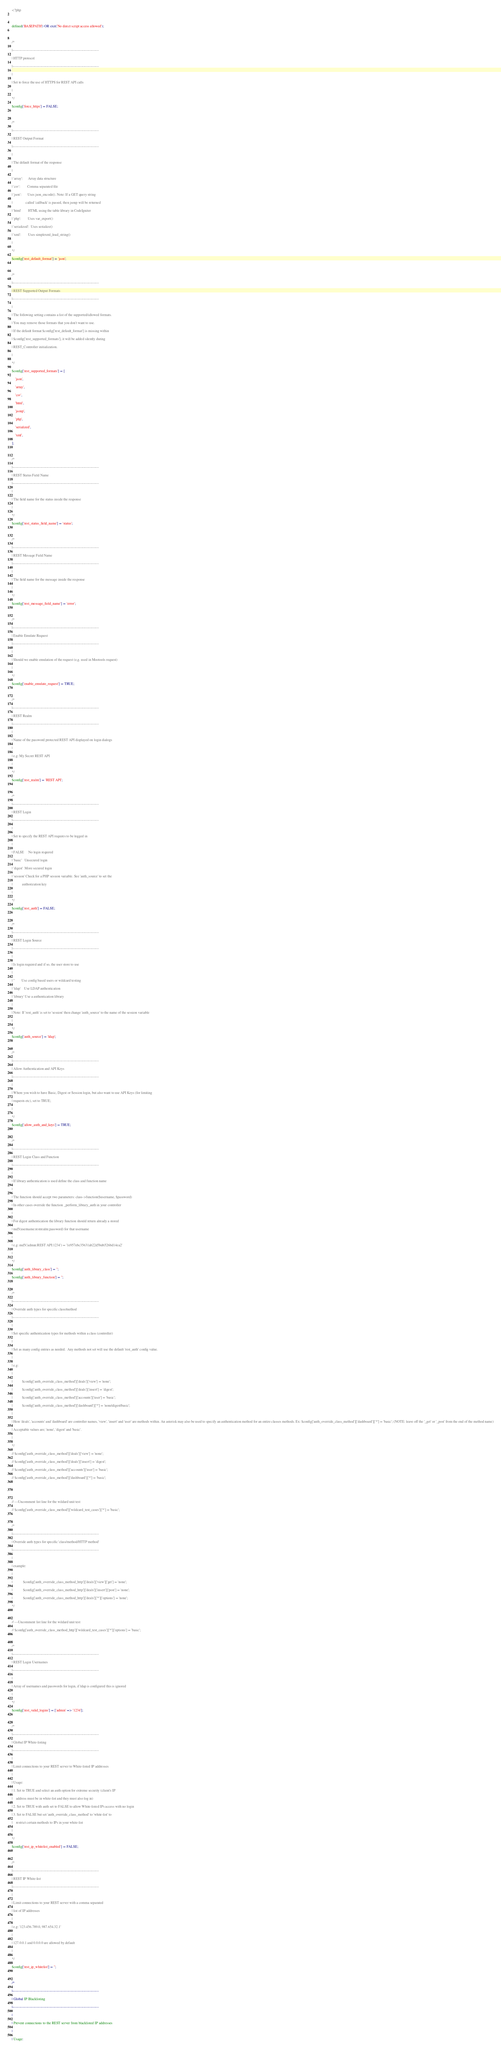Convert code to text. <code><loc_0><loc_0><loc_500><loc_500><_PHP_><?php

defined('BASEPATH') OR exit('No direct script access allowed');

/*
|--------------------------------------------------------------------------
| HTTP protocol
|--------------------------------------------------------------------------
|
| Set to force the use of HTTPS for REST API calls
|
*/
$config['force_https'] = FALSE;

/*
|--------------------------------------------------------------------------
| REST Output Format
|--------------------------------------------------------------------------
|
| The default format of the response
|
| 'array':      Array data structure
| 'csv':        Comma separated file
| 'json':       Uses json_encode(). Note: If a GET query string
|               called 'callback' is passed, then jsonp will be returned
| 'html'        HTML using the table library in CodeIgniter
| 'php':        Uses var_export()
| 'serialized':  Uses serialize()
| 'xml':        Uses simplexml_load_string()
|
*/
$config['rest_default_format'] = 'json';

/*
|--------------------------------------------------------------------------
| REST Supported Output Formats
|--------------------------------------------------------------------------
|
| The following setting contains a list of the supported/allowed formats.
| You may remove those formats that you don't want to use.
| If the default format $config['rest_default_format'] is missing within
| $config['rest_supported_formats'], it will be added silently during
| REST_Controller initialization.
|
*/
$config['rest_supported_formats'] = [
    'json',
    'array',
    'csv',
    'html',
    'jsonp',
    'php',
    'serialized',
    'xml',
];

/*
|--------------------------------------------------------------------------
| REST Status Field Name
|--------------------------------------------------------------------------
|
| The field name for the status inside the response
|
*/
$config['rest_status_field_name'] = 'status';

/*
|--------------------------------------------------------------------------
| REST Message Field Name
|--------------------------------------------------------------------------
|
| The field name for the message inside the response
|
*/
$config['rest_message_field_name'] = 'error';

/*
|--------------------------------------------------------------------------
| Enable Emulate Request
|--------------------------------------------------------------------------
|
| Should we enable emulation of the request (e.g. used in Mootools request)
|
*/
$config['enable_emulate_request'] = TRUE;

/*
|--------------------------------------------------------------------------
| REST Realm
|--------------------------------------------------------------------------
|
| Name of the password protected REST API displayed on login dialogs
|
| e.g: My Secret REST API
|
*/
$config['rest_realm'] = 'REST API';

/*
|--------------------------------------------------------------------------
| REST Login
|--------------------------------------------------------------------------
|
| Set to specify the REST API requires to be logged in
|
| FALSE     No login required
| 'basic'   Unsecured login
| 'digest'  More secured login
| 'session' Check for a PHP session variable. See 'auth_source' to set the
|           authorization key
|
*/
$config['rest_auth'] = FALSE;

/*
|--------------------------------------------------------------------------
| REST Login Source
|--------------------------------------------------------------------------
|
| Is login required and if so, the user store to use
|
| ''        Use config based users or wildcard testing
| 'ldap'    Use LDAP authentication
| 'library' Use a authentication library
|
| Note: If 'rest_auth' is set to 'session' then change 'auth_source' to the name of the session variable
|
*/
$config['auth_source'] = 'ldap';

/*
|--------------------------------------------------------------------------
| Allow Authentication and API Keys
|--------------------------------------------------------------------------
|
| Where you wish to have Basic, Digest or Session login, but also want to use API Keys (for limiting
| requests etc), set to TRUE;
|
*/
$config['allow_auth_and_keys'] = TRUE;

/*
|--------------------------------------------------------------------------
| REST Login Class and Function
|--------------------------------------------------------------------------
|
| If library authentication is used define the class and function name
|
| The function should accept two parameters: class->function($username, $password)
| In other cases override the function _perform_library_auth in your controller
|
| For digest authentication the library function should return already a stored
| md5(username:restrealm:password) for that username
|
| e.g: md5('admin:REST API:1234') = '1e957ebc35631ab22d5bd6526bd14ea2'
|
*/
$config['auth_library_class'] = '';
$config['auth_library_function'] = '';

/*
|--------------------------------------------------------------------------
| Override auth types for specific class/method
|--------------------------------------------------------------------------
|
| Set specific authentication types for methods within a class (controller)
|
| Set as many config entries as needed.  Any methods not set will use the default 'rest_auth' config value.
|
| e.g:
|
|           $config['auth_override_class_method']['deals']['view'] = 'none';
|           $config['auth_override_class_method']['deals']['insert'] = 'digest';
|           $config['auth_override_class_method']['accounts']['user'] = 'basic';
|           $config['auth_override_class_method']['dashboard']['*'] = 'none|digest|basic';
|
| Here 'deals', 'accounts' and 'dashboard' are controller names, 'view', 'insert' and 'user' are methods within. An asterisk may also be used to specify an authentication method for an entire classes methods. Ex: $config['auth_override_class_method']['dashboard']['*'] = 'basic'; (NOTE: leave off the '_get' or '_post' from the end of the method name)
| Acceptable values are; 'none', 'digest' and 'basic'.
|
*/
// $config['auth_override_class_method']['deals']['view'] = 'none';
// $config['auth_override_class_method']['deals']['insert'] = 'digest';
// $config['auth_override_class_method']['accounts']['user'] = 'basic';
// $config['auth_override_class_method']['dashboard']['*'] = 'basic';


// ---Uncomment list line for the wildard unit test
// $config['auth_override_class_method']['wildcard_test_cases']['*'] = 'basic';

/*
|--------------------------------------------------------------------------
| Override auth types for specific 'class/method/HTTP method'
|--------------------------------------------------------------------------
|
| example:
|
|            $config['auth_override_class_method_http']['deals']['view']['get'] = 'none';
|            $config['auth_override_class_method_http']['deals']['insert']['post'] = 'none';
|            $config['auth_override_class_method_http']['deals']['*']['options'] = 'none';
*/

// ---Uncomment list line for the wildard unit test
// $config['auth_override_class_method_http']['wildcard_test_cases']['*']['options'] = 'basic';

/*
|--------------------------------------------------------------------------
| REST Login Usernames
|--------------------------------------------------------------------------
|
| Array of usernames and passwords for login, if ldap is configured this is ignored
|
*/
$config['rest_valid_logins'] = ['admin' => '1234'];

/*
|--------------------------------------------------------------------------
| Global IP White-listing
|--------------------------------------------------------------------------
|
| Limit connections to your REST server to White-listed IP addresses
|
| Usage:
| 1. Set to TRUE and select an auth option for extreme security (client's IP
|    address must be in white-list and they must also log in)
| 2. Set to TRUE with auth set to FALSE to allow White-listed IPs access with no login
| 3. Set to FALSE but set 'auth_override_class_method' to 'white-list' to
|    restrict certain methods to IPs in your white-list
|
*/
$config['rest_ip_whitelist_enabled'] = FALSE;

/*
|--------------------------------------------------------------------------
| REST IP White-list
|--------------------------------------------------------------------------
|
| Limit connections to your REST server with a comma separated
| list of IP addresses
|
| e.g: '123.456.789.0, 987.654.32.1'
|
| 127.0.0.1 and 0.0.0.0 are allowed by default
|
*/
$config['rest_ip_whitelist'] = '';

/*
|--------------------------------------------------------------------------
| Global IP Blacklisting
|--------------------------------------------------------------------------
|
| Prevent connections to the REST server from blacklisted IP addresses
|
| Usage:</code> 